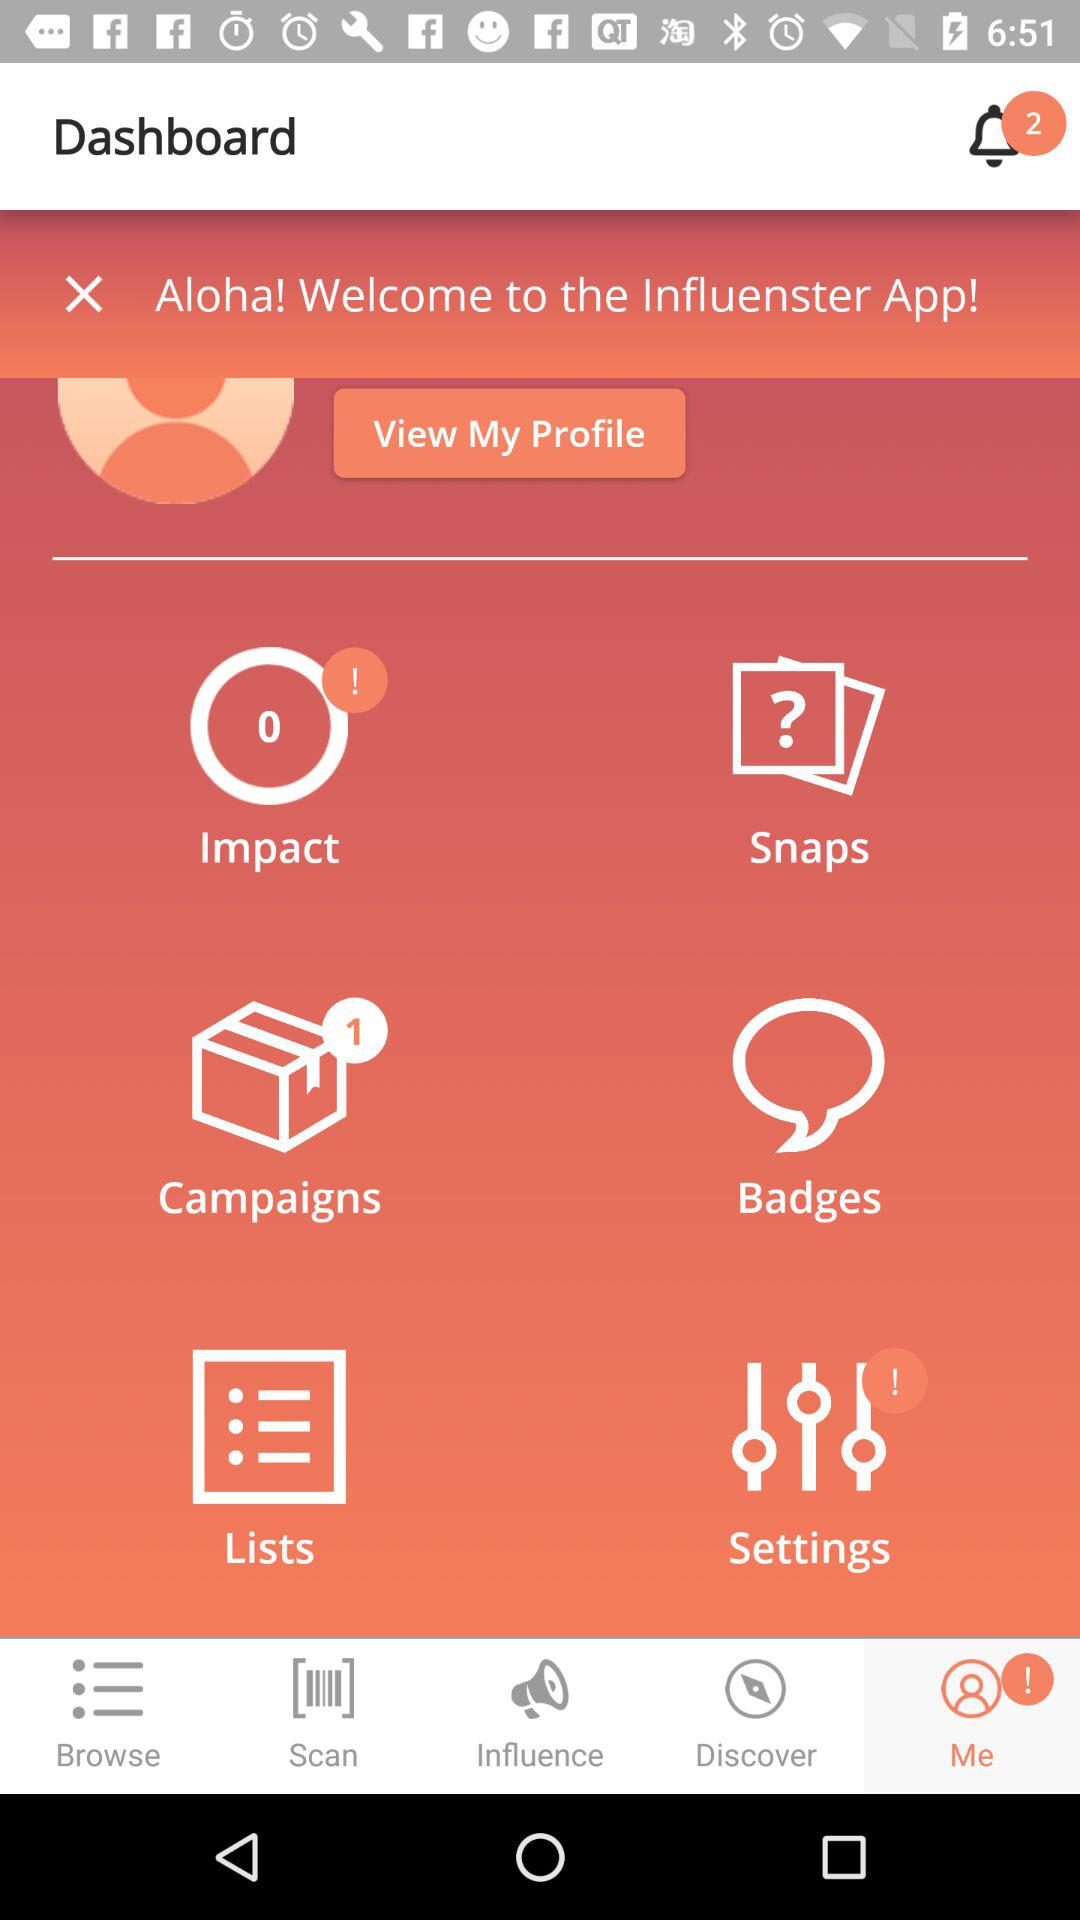Which tab is currently selected? The selected tab is "Me". 